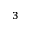<formula> <loc_0><loc_0><loc_500><loc_500>^ { 3 }</formula> 